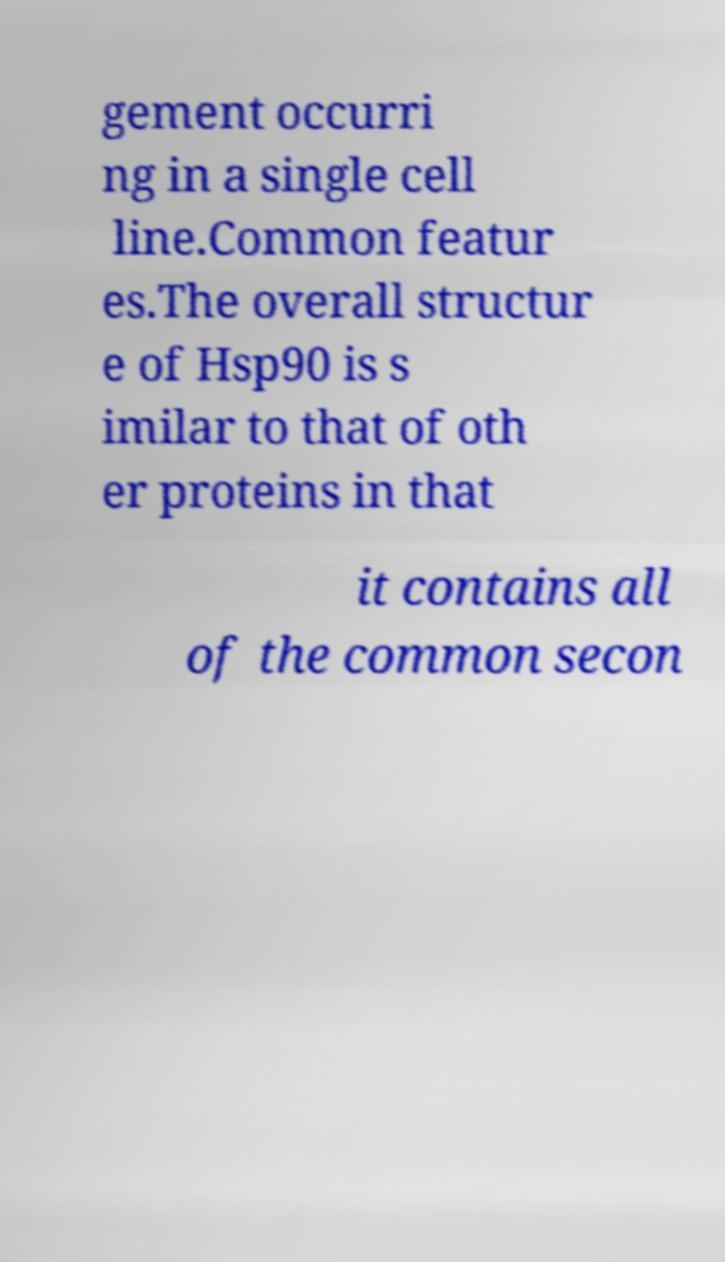What messages or text are displayed in this image? I need them in a readable, typed format. gement occurri ng in a single cell line.Common featur es.The overall structur e of Hsp90 is s imilar to that of oth er proteins in that it contains all of the common secon 